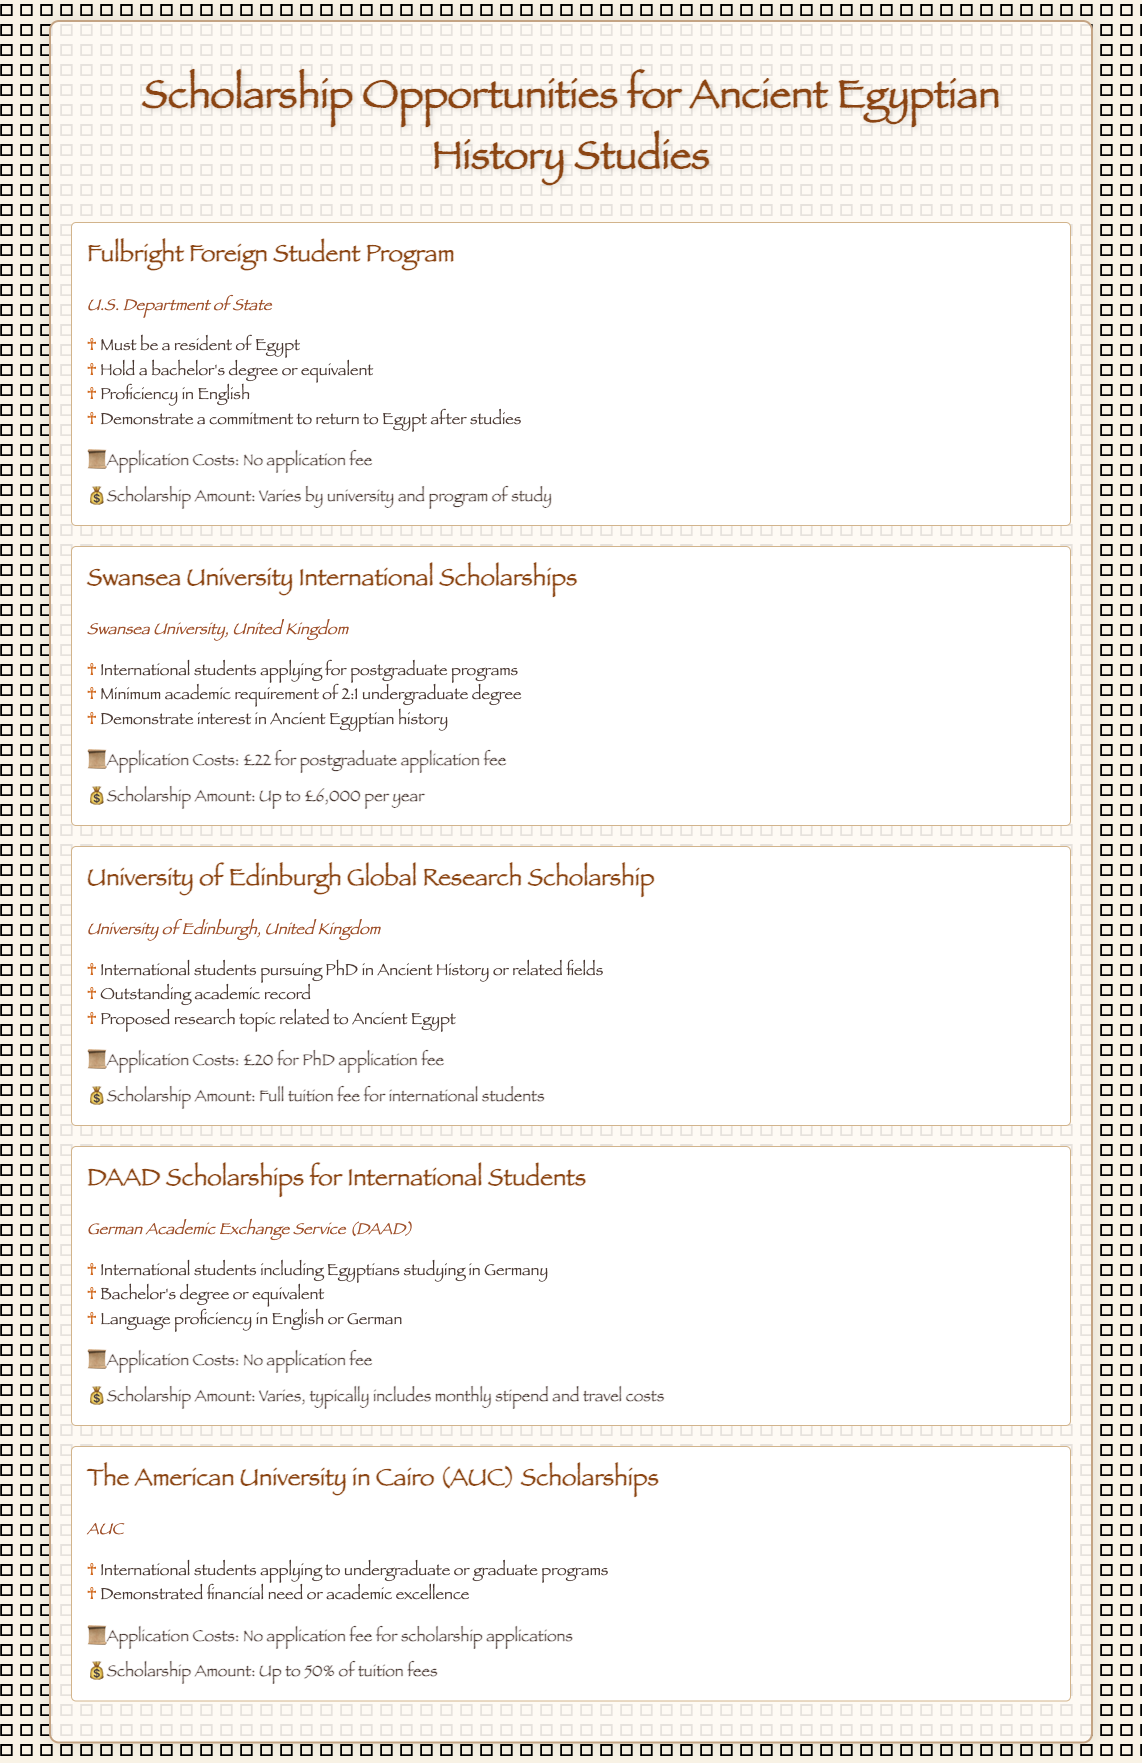what is the name of the scholarship offered by the U.S. Department of State? The scholarship offered by the U.S. Department of State for studying Ancient Egyptian history is called the Fulbright Foreign Student Program.
Answer: Fulbright Foreign Student Program what is the maximum scholarship amount for Swansea University International Scholarships? The scholarship amount for Swansea University International Scholarships is specified as "Up to £6,000 per year."
Answer: Up to £6,000 per year how much is the application fee for the University of Edinburgh Global Research Scholarship? The application fee for the University of Edinburgh Global Research Scholarship is stated as "£20 for PhD application fee."
Answer: £20 which organization offers the DAAD Scholarships for International Students? The DAAD Scholarships for International Students are offered by the German Academic Exchange Service (DAAD).
Answer: German Academic Exchange Service (DAAD) what is a requirement for the Fulbright Foreign Student Program? A requirement for the Fulbright Foreign Student Program is that applicants must hold a bachelor's degree or equivalent.
Answer: Hold a bachelor's degree or equivalent which scholarship has a requirement to demonstrate interest in Ancient Egyptian history? The Swansea University International Scholarships has a requirement to demonstrate interest in Ancient Egyptian history.
Answer: Swansea University International Scholarships what is the scholarship amount for The American University in Cairo (AUC) Scholarships? The scholarship amount for The American University in Cairo (AUC) Scholarships is "Up to 50% of tuition fees."
Answer: Up to 50% of tuition fees what language proficiency is required for DAAD Scholarships? For DAAD Scholarships, language proficiency in English or German is required.
Answer: English or German how many scholarships are offered for international students in this document? The document lists five different scholarship opportunities for international students studying Ancient Egyptian history.
Answer: Five 